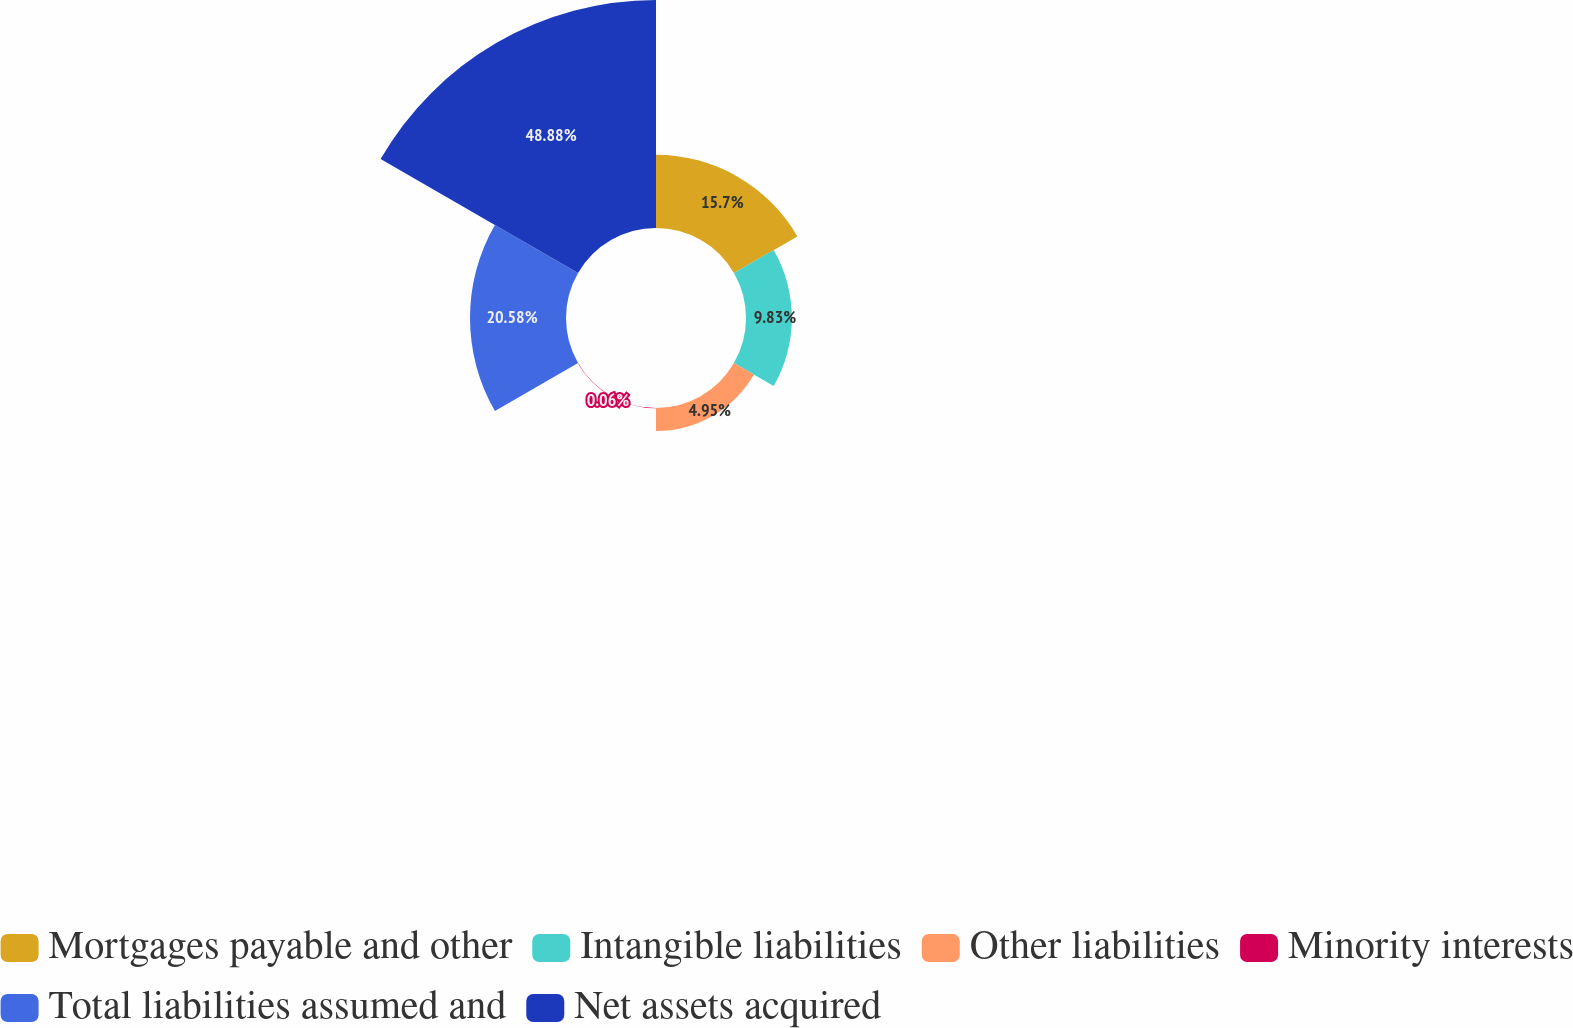<chart> <loc_0><loc_0><loc_500><loc_500><pie_chart><fcel>Mortgages payable and other<fcel>Intangible liabilities<fcel>Other liabilities<fcel>Minority interests<fcel>Total liabilities assumed and<fcel>Net assets acquired<nl><fcel>15.7%<fcel>9.83%<fcel>4.95%<fcel>0.06%<fcel>20.58%<fcel>48.88%<nl></chart> 